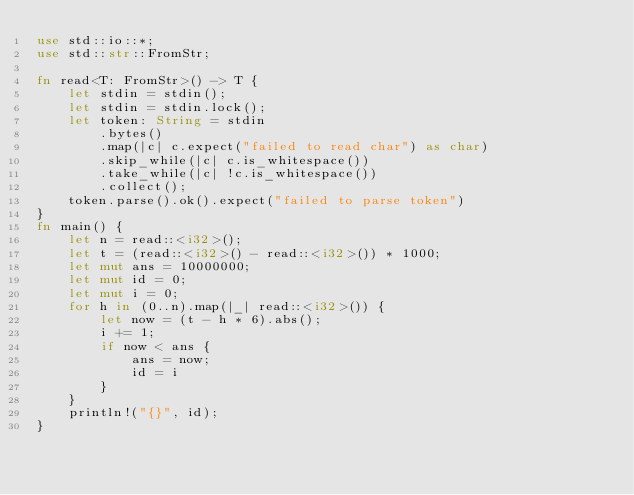<code> <loc_0><loc_0><loc_500><loc_500><_Rust_>use std::io::*;
use std::str::FromStr;

fn read<T: FromStr>() -> T {
    let stdin = stdin();
    let stdin = stdin.lock();
    let token: String = stdin
        .bytes()
        .map(|c| c.expect("failed to read char") as char)
        .skip_while(|c| c.is_whitespace())
        .take_while(|c| !c.is_whitespace())
        .collect();
    token.parse().ok().expect("failed to parse token")
}
fn main() {
    let n = read::<i32>();
    let t = (read::<i32>() - read::<i32>()) * 1000;
    let mut ans = 10000000;
    let mut id = 0;
    let mut i = 0;
    for h in (0..n).map(|_| read::<i32>()) {
        let now = (t - h * 6).abs();
        i += 1;
        if now < ans {
            ans = now;
            id = i
        }
    }
    println!("{}", id);
}
</code> 